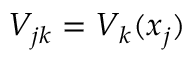Convert formula to latex. <formula><loc_0><loc_0><loc_500><loc_500>V _ { j k } = V _ { k } ( x _ { j } )</formula> 